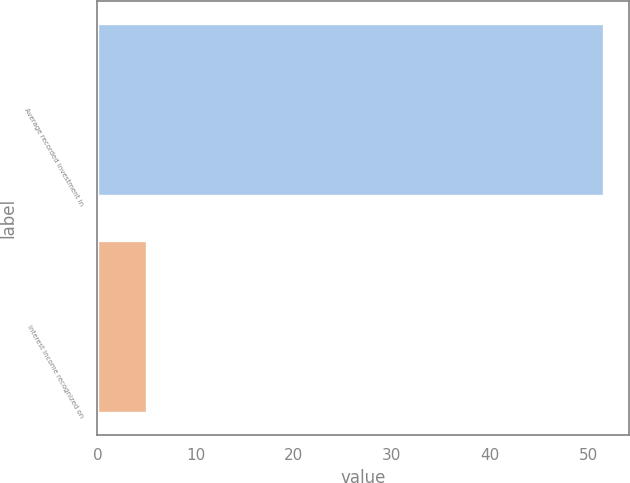Convert chart. <chart><loc_0><loc_0><loc_500><loc_500><bar_chart><fcel>Average recorded investment in<fcel>Interest income recognized on<nl><fcel>51.6<fcel>5.1<nl></chart> 